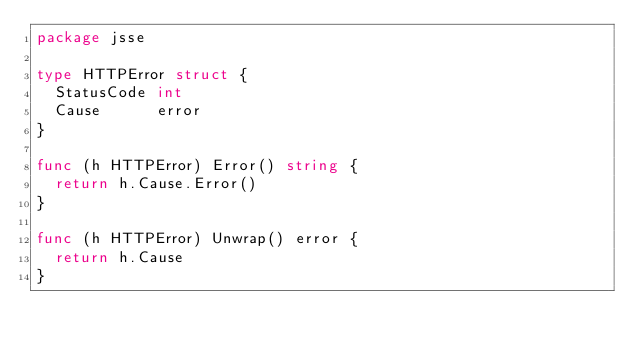Convert code to text. <code><loc_0><loc_0><loc_500><loc_500><_Go_>package jsse

type HTTPError struct {
	StatusCode int
	Cause      error
}

func (h HTTPError) Error() string {
	return h.Cause.Error()
}

func (h HTTPError) Unwrap() error {
	return h.Cause
}
</code> 